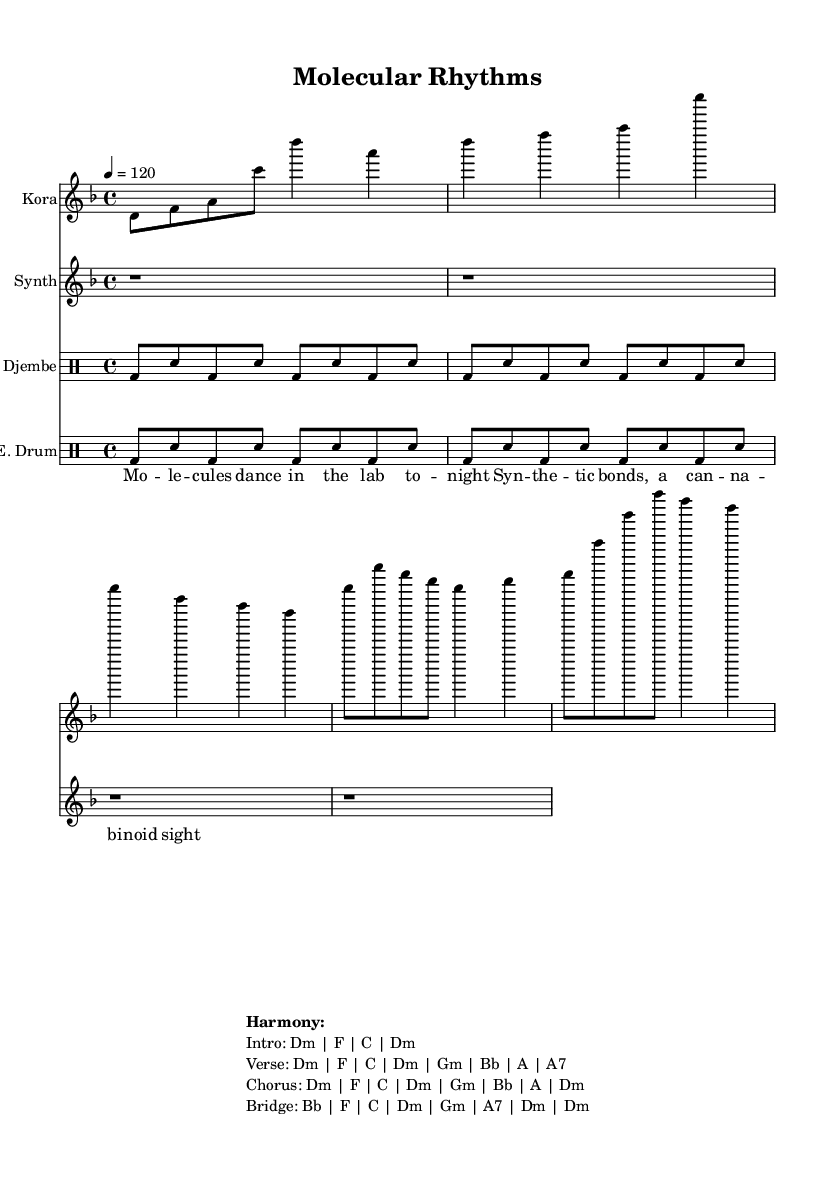What is the key signature of this music? The key signature is D minor, which has one flat (B♭). This can be confirmed by identifying the key signature mark at the beginning of the staff, which indicates D minor as the tonal center.
Answer: D minor What is the time signature of this music? The time signature is 4/4, which means there are four beats in each measure and the quarter note gets one beat. This is evident from the signature located at the beginning of the score above the staff.
Answer: 4/4 What is the tempo marking in this piece? The tempo marking is 120 beats per minute. This indicates that the music should be played at a brisk pace, which can be seen close to the start of the score where tempo instructions are provided.
Answer: 120 What instruments are used in this composition? The instruments used are Kora, Synth, Djembe, and E. Drum. You can find the instrument names clearly marked at the beginning of each staff in the score, representing each part played in the piece.
Answer: Kora, Synth, Djembe, E. Drum How many measures does the Kora part have? The Kora part consists of five measures, which can be counted by visually identifying the measure lines throughout the Kora staff. Each group of notes separated by vertical lines represents one measure.
Answer: 5 What is the primary style of this music based on its instrumentation? The primary style is African fusion. This can be inferred from the combination of traditional instrumentation like the Kora with electronic elements shown in the Synth and E. Drum parts, exemplifying a blend of cultural sounds.
Answer: African fusion Which section contains the lyrics, and what is its function? The section containing the lyrics is labeled "verse." It functions as the narrative part of the song where the themes related to the science of synthetic cannabinoids are expressed in a lyrical format, aligned with the music.
Answer: verse 